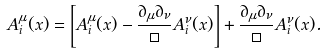Convert formula to latex. <formula><loc_0><loc_0><loc_500><loc_500>A ^ { \mu } _ { i } ( x ) = \left [ A ^ { \mu } _ { i } ( x ) - \frac { \partial _ { \mu } \partial _ { \nu } } { \Box } A ^ { \nu } _ { i } ( x ) \right ] + \frac { \partial _ { \mu } \partial _ { \nu } } { \Box } A ^ { \nu } _ { i } ( x ) .</formula> 